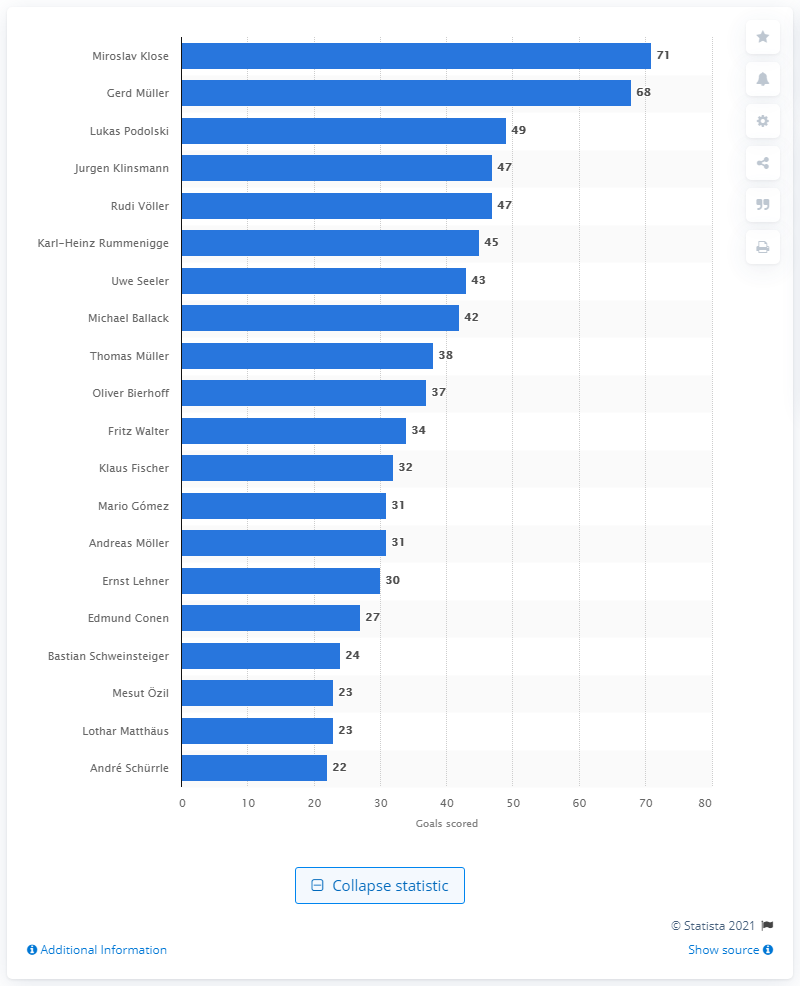Draw attention to some important aspects in this diagram. Miroslav Klose is the all-time leader in goals scored for the national football team of Germany. Lukas Podolski is the all-time leader in goals scored for the national football team of Germany. 